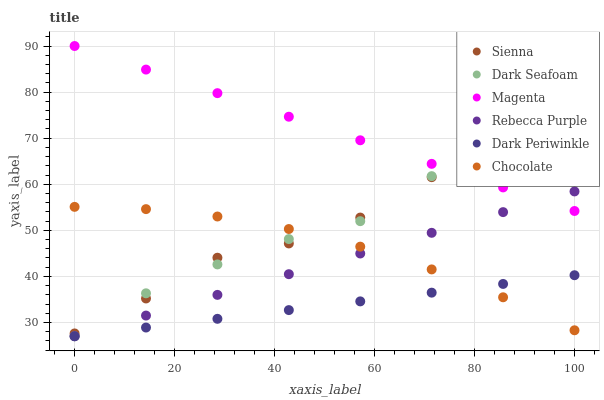Does Dark Periwinkle have the minimum area under the curve?
Answer yes or no. Yes. Does Magenta have the maximum area under the curve?
Answer yes or no. Yes. Does Sienna have the minimum area under the curve?
Answer yes or no. No. Does Sienna have the maximum area under the curve?
Answer yes or no. No. Is Dark Periwinkle the smoothest?
Answer yes or no. Yes. Is Sienna the roughest?
Answer yes or no. Yes. Is Dark Seafoam the smoothest?
Answer yes or no. No. Is Dark Seafoam the roughest?
Answer yes or no. No. Does Dark Seafoam have the lowest value?
Answer yes or no. Yes. Does Sienna have the lowest value?
Answer yes or no. No. Does Magenta have the highest value?
Answer yes or no. Yes. Does Sienna have the highest value?
Answer yes or no. No. Is Dark Periwinkle less than Magenta?
Answer yes or no. Yes. Is Sienna greater than Rebecca Purple?
Answer yes or no. Yes. Does Dark Periwinkle intersect Rebecca Purple?
Answer yes or no. Yes. Is Dark Periwinkle less than Rebecca Purple?
Answer yes or no. No. Is Dark Periwinkle greater than Rebecca Purple?
Answer yes or no. No. Does Dark Periwinkle intersect Magenta?
Answer yes or no. No. 